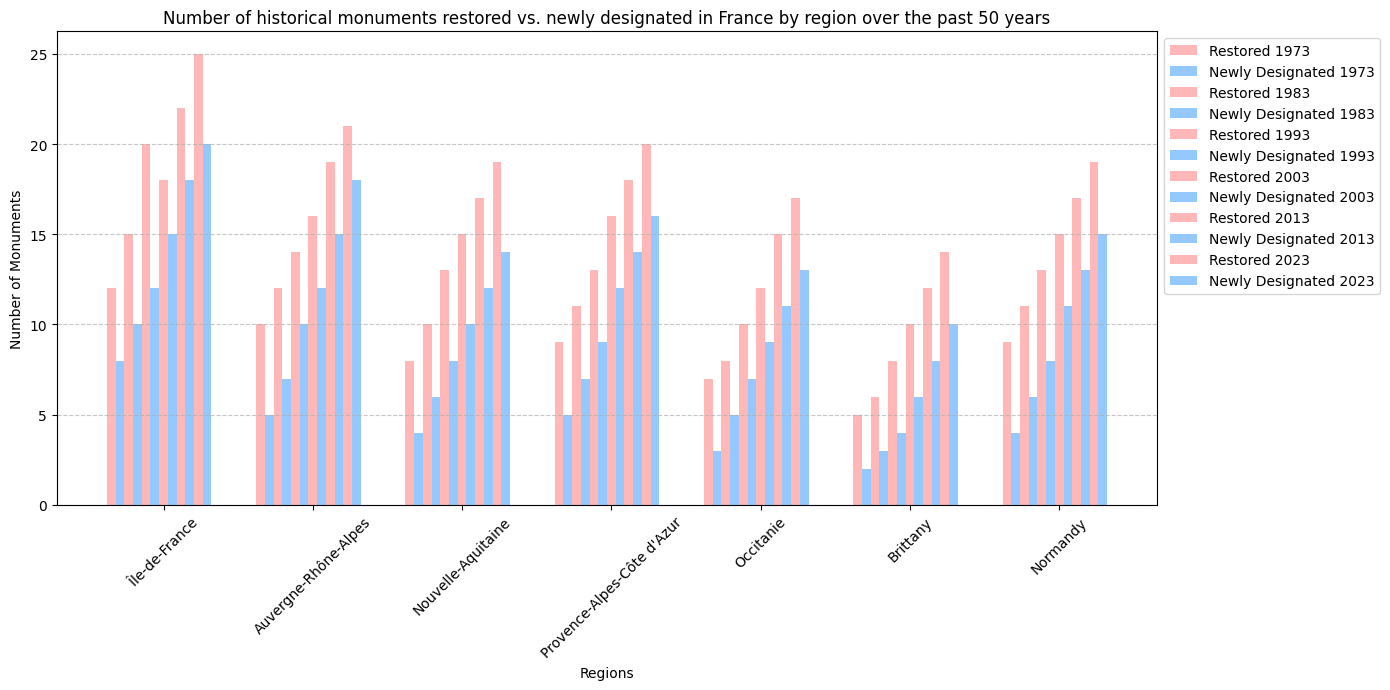Which region had the most monuments restored in 2023? Observe the height of the bars for 2023 under the 'Restored' category; Île-de-France has the tallest bar.
Answer: Île-de-France Which region had the least newly designated monuments in 1973? Check the height of the bars for 1973 under the 'Newly Designated' category; Brittany has the shortest bar.
Answer: Brittany Compare the number of restored monuments in Île-de-France and Provence-Alpes-Côte d'Azur in 1993. Which region restored more monuments? For 1993, the height of the 'Restored' bar is taller for Île-de-France compared to Provence-Alpes-Côte d'Azur.
Answer: Île-de-France What is the total number of newly designated monuments in Occitanie between 2003 and 2023? Sum the heights of the 'Newly Designated' bars for Occitanie for the years 2003, 2013, and 2023: 9 + 11 + 13 = 33.
Answer: 33 Were there more monuments restored or newly designated in Normandy in the year 2013? Compare the height of the bars in Normandy for 2013; the 'Restored' bar (17) is taller than the 'Newly Designated' bar (13).
Answer: Restored Which year had the highest total number of restored monuments across all regions? Sum the heights of the 'Restored' bars for each year, and compare: 2023 has the highest total.
Answer: 2023 In what year and region were the newly designated monuments equivalent to the 10 restored monuments in Brittany in 1993? Locate the bar for newly designated monuments in each region-year combination; the bar in Auvergne-Rhône-Alpes for 1983 is close to 10 newly designated ones.
Answer: Auvergne-Rhône-Alpes, 1983 Which region has consistently increased the number of restored monuments over the 50 years? Check the trend for each region; Île-de-France's 'Restored' bars show a consistent increase every decade.
Answer: Île-de-France 